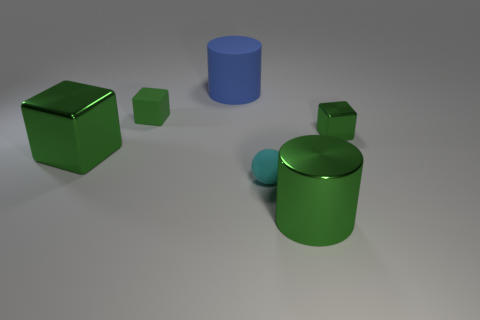There is a cyan thing; is it the same shape as the shiny object on the left side of the blue matte object?
Your answer should be compact. No. What is the blue object made of?
Provide a succinct answer. Rubber. There is a rubber thing on the left side of the cylinder behind the metal cube behind the large green cube; what color is it?
Your answer should be compact. Green. There is a large green thing that is the same shape as the large blue matte object; what is its material?
Your answer should be compact. Metal. What number of metal blocks have the same size as the green rubber cube?
Ensure brevity in your answer.  1. How many blue cylinders are there?
Give a very brief answer. 1. Are the cyan sphere and the big green object on the left side of the large blue cylinder made of the same material?
Ensure brevity in your answer.  No. What number of blue objects are metal objects or tiny rubber cubes?
Your answer should be very brief. 0. The block that is the same material as the blue object is what size?
Offer a terse response. Small. What number of big green objects have the same shape as the blue thing?
Keep it short and to the point. 1. 